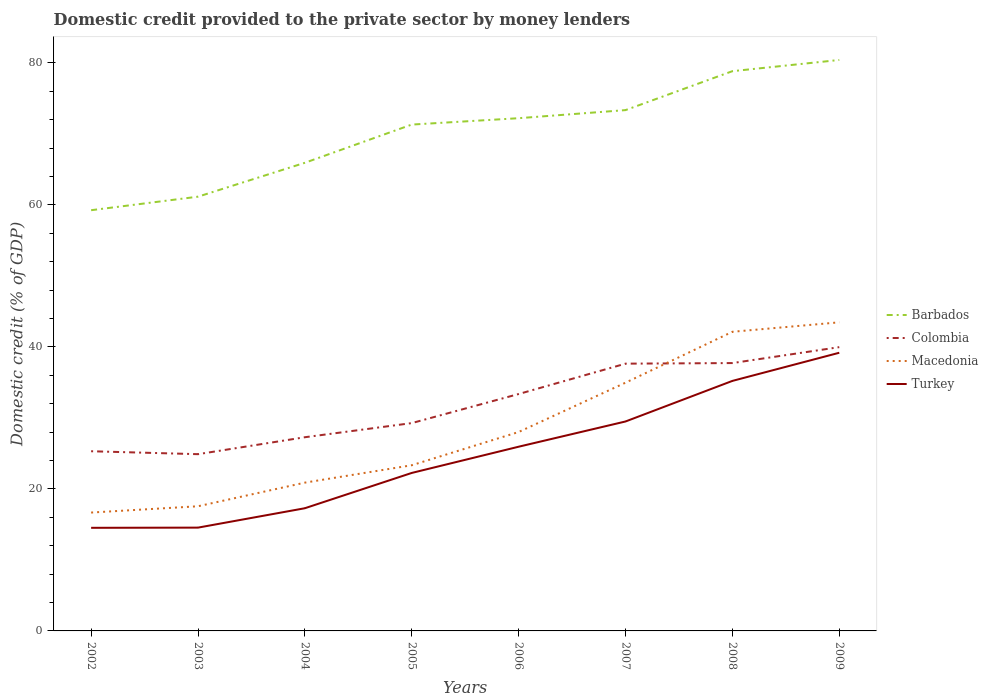Does the line corresponding to Colombia intersect with the line corresponding to Macedonia?
Ensure brevity in your answer.  Yes. Across all years, what is the maximum domestic credit provided to the private sector by money lenders in Macedonia?
Give a very brief answer. 16.67. What is the total domestic credit provided to the private sector by money lenders in Colombia in the graph?
Provide a short and direct response. -6.09. What is the difference between the highest and the second highest domestic credit provided to the private sector by money lenders in Colombia?
Give a very brief answer. 15.07. How many lines are there?
Offer a terse response. 4. How many years are there in the graph?
Ensure brevity in your answer.  8. What is the difference between two consecutive major ticks on the Y-axis?
Make the answer very short. 20. Are the values on the major ticks of Y-axis written in scientific E-notation?
Your answer should be compact. No. Does the graph contain grids?
Provide a short and direct response. No. Where does the legend appear in the graph?
Make the answer very short. Center right. How many legend labels are there?
Your response must be concise. 4. What is the title of the graph?
Keep it short and to the point. Domestic credit provided to the private sector by money lenders. Does "Serbia" appear as one of the legend labels in the graph?
Make the answer very short. No. What is the label or title of the Y-axis?
Provide a succinct answer. Domestic credit (% of GDP). What is the Domestic credit (% of GDP) in Barbados in 2002?
Offer a very short reply. 59.25. What is the Domestic credit (% of GDP) of Colombia in 2002?
Your response must be concise. 25.3. What is the Domestic credit (% of GDP) of Macedonia in 2002?
Provide a short and direct response. 16.67. What is the Domestic credit (% of GDP) of Turkey in 2002?
Offer a very short reply. 14.52. What is the Domestic credit (% of GDP) of Barbados in 2003?
Keep it short and to the point. 61.15. What is the Domestic credit (% of GDP) in Colombia in 2003?
Keep it short and to the point. 24.89. What is the Domestic credit (% of GDP) of Macedonia in 2003?
Ensure brevity in your answer.  17.56. What is the Domestic credit (% of GDP) in Turkey in 2003?
Your answer should be compact. 14.55. What is the Domestic credit (% of GDP) of Barbados in 2004?
Make the answer very short. 65.93. What is the Domestic credit (% of GDP) of Colombia in 2004?
Make the answer very short. 27.28. What is the Domestic credit (% of GDP) in Macedonia in 2004?
Offer a terse response. 20.88. What is the Domestic credit (% of GDP) of Turkey in 2004?
Keep it short and to the point. 17.28. What is the Domestic credit (% of GDP) of Barbados in 2005?
Give a very brief answer. 71.31. What is the Domestic credit (% of GDP) of Colombia in 2005?
Ensure brevity in your answer.  29.27. What is the Domestic credit (% of GDP) of Macedonia in 2005?
Your answer should be very brief. 23.33. What is the Domestic credit (% of GDP) of Turkey in 2005?
Provide a succinct answer. 22.25. What is the Domestic credit (% of GDP) in Barbados in 2006?
Your response must be concise. 72.21. What is the Domestic credit (% of GDP) in Colombia in 2006?
Your response must be concise. 33.36. What is the Domestic credit (% of GDP) in Macedonia in 2006?
Provide a short and direct response. 28.01. What is the Domestic credit (% of GDP) in Turkey in 2006?
Give a very brief answer. 25.94. What is the Domestic credit (% of GDP) in Barbados in 2007?
Offer a terse response. 73.35. What is the Domestic credit (% of GDP) in Colombia in 2007?
Offer a very short reply. 37.64. What is the Domestic credit (% of GDP) in Macedonia in 2007?
Give a very brief answer. 34.96. What is the Domestic credit (% of GDP) in Turkey in 2007?
Make the answer very short. 29.5. What is the Domestic credit (% of GDP) in Barbados in 2008?
Keep it short and to the point. 78.83. What is the Domestic credit (% of GDP) of Colombia in 2008?
Offer a very short reply. 37.72. What is the Domestic credit (% of GDP) in Macedonia in 2008?
Your answer should be very brief. 42.13. What is the Domestic credit (% of GDP) in Turkey in 2008?
Your answer should be compact. 35.21. What is the Domestic credit (% of GDP) in Barbados in 2009?
Your response must be concise. 80.41. What is the Domestic credit (% of GDP) of Colombia in 2009?
Your answer should be very brief. 39.96. What is the Domestic credit (% of GDP) of Macedonia in 2009?
Your answer should be compact. 43.46. What is the Domestic credit (% of GDP) in Turkey in 2009?
Provide a succinct answer. 39.18. Across all years, what is the maximum Domestic credit (% of GDP) in Barbados?
Your answer should be very brief. 80.41. Across all years, what is the maximum Domestic credit (% of GDP) of Colombia?
Your answer should be compact. 39.96. Across all years, what is the maximum Domestic credit (% of GDP) of Macedonia?
Ensure brevity in your answer.  43.46. Across all years, what is the maximum Domestic credit (% of GDP) of Turkey?
Keep it short and to the point. 39.18. Across all years, what is the minimum Domestic credit (% of GDP) in Barbados?
Your answer should be compact. 59.25. Across all years, what is the minimum Domestic credit (% of GDP) in Colombia?
Provide a short and direct response. 24.89. Across all years, what is the minimum Domestic credit (% of GDP) of Macedonia?
Make the answer very short. 16.67. Across all years, what is the minimum Domestic credit (% of GDP) of Turkey?
Provide a succinct answer. 14.52. What is the total Domestic credit (% of GDP) of Barbados in the graph?
Provide a short and direct response. 562.43. What is the total Domestic credit (% of GDP) of Colombia in the graph?
Your response must be concise. 255.43. What is the total Domestic credit (% of GDP) in Macedonia in the graph?
Provide a short and direct response. 227. What is the total Domestic credit (% of GDP) in Turkey in the graph?
Offer a very short reply. 198.42. What is the difference between the Domestic credit (% of GDP) of Barbados in 2002 and that in 2003?
Ensure brevity in your answer.  -1.91. What is the difference between the Domestic credit (% of GDP) of Colombia in 2002 and that in 2003?
Provide a succinct answer. 0.41. What is the difference between the Domestic credit (% of GDP) in Macedonia in 2002 and that in 2003?
Provide a short and direct response. -0.89. What is the difference between the Domestic credit (% of GDP) of Turkey in 2002 and that in 2003?
Offer a very short reply. -0.03. What is the difference between the Domestic credit (% of GDP) of Barbados in 2002 and that in 2004?
Your response must be concise. -6.68. What is the difference between the Domestic credit (% of GDP) of Colombia in 2002 and that in 2004?
Offer a terse response. -1.97. What is the difference between the Domestic credit (% of GDP) of Macedonia in 2002 and that in 2004?
Make the answer very short. -4.21. What is the difference between the Domestic credit (% of GDP) in Turkey in 2002 and that in 2004?
Offer a terse response. -2.76. What is the difference between the Domestic credit (% of GDP) in Barbados in 2002 and that in 2005?
Provide a short and direct response. -12.06. What is the difference between the Domestic credit (% of GDP) of Colombia in 2002 and that in 2005?
Make the answer very short. -3.96. What is the difference between the Domestic credit (% of GDP) of Macedonia in 2002 and that in 2005?
Your answer should be compact. -6.66. What is the difference between the Domestic credit (% of GDP) of Turkey in 2002 and that in 2005?
Your answer should be very brief. -7.73. What is the difference between the Domestic credit (% of GDP) in Barbados in 2002 and that in 2006?
Your response must be concise. -12.96. What is the difference between the Domestic credit (% of GDP) of Colombia in 2002 and that in 2006?
Your response must be concise. -8.06. What is the difference between the Domestic credit (% of GDP) in Macedonia in 2002 and that in 2006?
Your response must be concise. -11.34. What is the difference between the Domestic credit (% of GDP) in Turkey in 2002 and that in 2006?
Give a very brief answer. -11.42. What is the difference between the Domestic credit (% of GDP) of Barbados in 2002 and that in 2007?
Offer a terse response. -14.1. What is the difference between the Domestic credit (% of GDP) in Colombia in 2002 and that in 2007?
Offer a very short reply. -12.34. What is the difference between the Domestic credit (% of GDP) in Macedonia in 2002 and that in 2007?
Ensure brevity in your answer.  -18.29. What is the difference between the Domestic credit (% of GDP) in Turkey in 2002 and that in 2007?
Provide a succinct answer. -14.97. What is the difference between the Domestic credit (% of GDP) of Barbados in 2002 and that in 2008?
Ensure brevity in your answer.  -19.58. What is the difference between the Domestic credit (% of GDP) of Colombia in 2002 and that in 2008?
Give a very brief answer. -12.42. What is the difference between the Domestic credit (% of GDP) in Macedonia in 2002 and that in 2008?
Provide a succinct answer. -25.46. What is the difference between the Domestic credit (% of GDP) of Turkey in 2002 and that in 2008?
Offer a very short reply. -20.69. What is the difference between the Domestic credit (% of GDP) in Barbados in 2002 and that in 2009?
Your response must be concise. -21.16. What is the difference between the Domestic credit (% of GDP) in Colombia in 2002 and that in 2009?
Provide a short and direct response. -14.66. What is the difference between the Domestic credit (% of GDP) in Macedonia in 2002 and that in 2009?
Provide a succinct answer. -26.79. What is the difference between the Domestic credit (% of GDP) in Turkey in 2002 and that in 2009?
Provide a short and direct response. -24.65. What is the difference between the Domestic credit (% of GDP) of Barbados in 2003 and that in 2004?
Offer a terse response. -4.77. What is the difference between the Domestic credit (% of GDP) in Colombia in 2003 and that in 2004?
Your answer should be compact. -2.39. What is the difference between the Domestic credit (% of GDP) of Macedonia in 2003 and that in 2004?
Offer a terse response. -3.33. What is the difference between the Domestic credit (% of GDP) of Turkey in 2003 and that in 2004?
Your response must be concise. -2.73. What is the difference between the Domestic credit (% of GDP) in Barbados in 2003 and that in 2005?
Provide a succinct answer. -10.15. What is the difference between the Domestic credit (% of GDP) of Colombia in 2003 and that in 2005?
Your answer should be compact. -4.38. What is the difference between the Domestic credit (% of GDP) in Macedonia in 2003 and that in 2005?
Give a very brief answer. -5.78. What is the difference between the Domestic credit (% of GDP) of Turkey in 2003 and that in 2005?
Provide a succinct answer. -7.7. What is the difference between the Domestic credit (% of GDP) of Barbados in 2003 and that in 2006?
Your answer should be compact. -11.05. What is the difference between the Domestic credit (% of GDP) of Colombia in 2003 and that in 2006?
Ensure brevity in your answer.  -8.47. What is the difference between the Domestic credit (% of GDP) of Macedonia in 2003 and that in 2006?
Give a very brief answer. -10.46. What is the difference between the Domestic credit (% of GDP) of Turkey in 2003 and that in 2006?
Keep it short and to the point. -11.4. What is the difference between the Domestic credit (% of GDP) of Barbados in 2003 and that in 2007?
Your answer should be compact. -12.19. What is the difference between the Domestic credit (% of GDP) in Colombia in 2003 and that in 2007?
Make the answer very short. -12.75. What is the difference between the Domestic credit (% of GDP) in Macedonia in 2003 and that in 2007?
Offer a very short reply. -17.41. What is the difference between the Domestic credit (% of GDP) in Turkey in 2003 and that in 2007?
Give a very brief answer. -14.95. What is the difference between the Domestic credit (% of GDP) of Barbados in 2003 and that in 2008?
Give a very brief answer. -17.67. What is the difference between the Domestic credit (% of GDP) of Colombia in 2003 and that in 2008?
Make the answer very short. -12.83. What is the difference between the Domestic credit (% of GDP) of Macedonia in 2003 and that in 2008?
Offer a very short reply. -24.57. What is the difference between the Domestic credit (% of GDP) in Turkey in 2003 and that in 2008?
Your answer should be compact. -20.66. What is the difference between the Domestic credit (% of GDP) in Barbados in 2003 and that in 2009?
Keep it short and to the point. -19.25. What is the difference between the Domestic credit (% of GDP) in Colombia in 2003 and that in 2009?
Make the answer very short. -15.07. What is the difference between the Domestic credit (% of GDP) of Macedonia in 2003 and that in 2009?
Keep it short and to the point. -25.9. What is the difference between the Domestic credit (% of GDP) of Turkey in 2003 and that in 2009?
Make the answer very short. -24.63. What is the difference between the Domestic credit (% of GDP) in Barbados in 2004 and that in 2005?
Give a very brief answer. -5.38. What is the difference between the Domestic credit (% of GDP) of Colombia in 2004 and that in 2005?
Offer a very short reply. -1.99. What is the difference between the Domestic credit (% of GDP) of Macedonia in 2004 and that in 2005?
Offer a very short reply. -2.45. What is the difference between the Domestic credit (% of GDP) of Turkey in 2004 and that in 2005?
Provide a short and direct response. -4.97. What is the difference between the Domestic credit (% of GDP) of Barbados in 2004 and that in 2006?
Your response must be concise. -6.28. What is the difference between the Domestic credit (% of GDP) of Colombia in 2004 and that in 2006?
Give a very brief answer. -6.09. What is the difference between the Domestic credit (% of GDP) of Macedonia in 2004 and that in 2006?
Provide a succinct answer. -7.13. What is the difference between the Domestic credit (% of GDP) in Turkey in 2004 and that in 2006?
Provide a short and direct response. -8.66. What is the difference between the Domestic credit (% of GDP) of Barbados in 2004 and that in 2007?
Offer a terse response. -7.42. What is the difference between the Domestic credit (% of GDP) in Colombia in 2004 and that in 2007?
Keep it short and to the point. -10.36. What is the difference between the Domestic credit (% of GDP) of Macedonia in 2004 and that in 2007?
Your answer should be compact. -14.08. What is the difference between the Domestic credit (% of GDP) in Turkey in 2004 and that in 2007?
Give a very brief answer. -12.22. What is the difference between the Domestic credit (% of GDP) of Barbados in 2004 and that in 2008?
Make the answer very short. -12.9. What is the difference between the Domestic credit (% of GDP) in Colombia in 2004 and that in 2008?
Your answer should be compact. -10.44. What is the difference between the Domestic credit (% of GDP) of Macedonia in 2004 and that in 2008?
Your answer should be compact. -21.24. What is the difference between the Domestic credit (% of GDP) in Turkey in 2004 and that in 2008?
Your answer should be very brief. -17.93. What is the difference between the Domestic credit (% of GDP) of Barbados in 2004 and that in 2009?
Your answer should be very brief. -14.48. What is the difference between the Domestic credit (% of GDP) in Colombia in 2004 and that in 2009?
Offer a terse response. -12.69. What is the difference between the Domestic credit (% of GDP) in Macedonia in 2004 and that in 2009?
Your response must be concise. -22.58. What is the difference between the Domestic credit (% of GDP) in Turkey in 2004 and that in 2009?
Offer a terse response. -21.9. What is the difference between the Domestic credit (% of GDP) in Barbados in 2005 and that in 2006?
Give a very brief answer. -0.9. What is the difference between the Domestic credit (% of GDP) of Colombia in 2005 and that in 2006?
Make the answer very short. -4.1. What is the difference between the Domestic credit (% of GDP) in Macedonia in 2005 and that in 2006?
Your answer should be very brief. -4.68. What is the difference between the Domestic credit (% of GDP) in Turkey in 2005 and that in 2006?
Your answer should be very brief. -3.69. What is the difference between the Domestic credit (% of GDP) of Barbados in 2005 and that in 2007?
Offer a very short reply. -2.04. What is the difference between the Domestic credit (% of GDP) of Colombia in 2005 and that in 2007?
Your answer should be very brief. -8.37. What is the difference between the Domestic credit (% of GDP) of Macedonia in 2005 and that in 2007?
Offer a terse response. -11.63. What is the difference between the Domestic credit (% of GDP) in Turkey in 2005 and that in 2007?
Provide a short and direct response. -7.25. What is the difference between the Domestic credit (% of GDP) in Barbados in 2005 and that in 2008?
Offer a terse response. -7.52. What is the difference between the Domestic credit (% of GDP) in Colombia in 2005 and that in 2008?
Keep it short and to the point. -8.45. What is the difference between the Domestic credit (% of GDP) of Macedonia in 2005 and that in 2008?
Your response must be concise. -18.8. What is the difference between the Domestic credit (% of GDP) of Turkey in 2005 and that in 2008?
Your answer should be very brief. -12.96. What is the difference between the Domestic credit (% of GDP) in Barbados in 2005 and that in 2009?
Your answer should be compact. -9.1. What is the difference between the Domestic credit (% of GDP) in Colombia in 2005 and that in 2009?
Give a very brief answer. -10.7. What is the difference between the Domestic credit (% of GDP) in Macedonia in 2005 and that in 2009?
Make the answer very short. -20.13. What is the difference between the Domestic credit (% of GDP) in Turkey in 2005 and that in 2009?
Your answer should be very brief. -16.93. What is the difference between the Domestic credit (% of GDP) in Barbados in 2006 and that in 2007?
Your response must be concise. -1.14. What is the difference between the Domestic credit (% of GDP) in Colombia in 2006 and that in 2007?
Provide a short and direct response. -4.28. What is the difference between the Domestic credit (% of GDP) in Macedonia in 2006 and that in 2007?
Your answer should be compact. -6.95. What is the difference between the Domestic credit (% of GDP) in Turkey in 2006 and that in 2007?
Give a very brief answer. -3.55. What is the difference between the Domestic credit (% of GDP) in Barbados in 2006 and that in 2008?
Your answer should be very brief. -6.62. What is the difference between the Domestic credit (% of GDP) of Colombia in 2006 and that in 2008?
Keep it short and to the point. -4.36. What is the difference between the Domestic credit (% of GDP) in Macedonia in 2006 and that in 2008?
Ensure brevity in your answer.  -14.11. What is the difference between the Domestic credit (% of GDP) of Turkey in 2006 and that in 2008?
Make the answer very short. -9.27. What is the difference between the Domestic credit (% of GDP) of Barbados in 2006 and that in 2009?
Give a very brief answer. -8.2. What is the difference between the Domestic credit (% of GDP) of Colombia in 2006 and that in 2009?
Provide a succinct answer. -6.6. What is the difference between the Domestic credit (% of GDP) of Macedonia in 2006 and that in 2009?
Your answer should be compact. -15.45. What is the difference between the Domestic credit (% of GDP) of Turkey in 2006 and that in 2009?
Offer a very short reply. -13.23. What is the difference between the Domestic credit (% of GDP) of Barbados in 2007 and that in 2008?
Provide a succinct answer. -5.48. What is the difference between the Domestic credit (% of GDP) of Colombia in 2007 and that in 2008?
Ensure brevity in your answer.  -0.08. What is the difference between the Domestic credit (% of GDP) of Macedonia in 2007 and that in 2008?
Ensure brevity in your answer.  -7.17. What is the difference between the Domestic credit (% of GDP) of Turkey in 2007 and that in 2008?
Offer a very short reply. -5.71. What is the difference between the Domestic credit (% of GDP) in Barbados in 2007 and that in 2009?
Your answer should be very brief. -7.06. What is the difference between the Domestic credit (% of GDP) of Colombia in 2007 and that in 2009?
Make the answer very short. -2.33. What is the difference between the Domestic credit (% of GDP) of Macedonia in 2007 and that in 2009?
Keep it short and to the point. -8.5. What is the difference between the Domestic credit (% of GDP) in Turkey in 2007 and that in 2009?
Give a very brief answer. -9.68. What is the difference between the Domestic credit (% of GDP) in Barbados in 2008 and that in 2009?
Make the answer very short. -1.58. What is the difference between the Domestic credit (% of GDP) in Colombia in 2008 and that in 2009?
Make the answer very short. -2.24. What is the difference between the Domestic credit (% of GDP) in Macedonia in 2008 and that in 2009?
Offer a very short reply. -1.33. What is the difference between the Domestic credit (% of GDP) of Turkey in 2008 and that in 2009?
Give a very brief answer. -3.96. What is the difference between the Domestic credit (% of GDP) in Barbados in 2002 and the Domestic credit (% of GDP) in Colombia in 2003?
Ensure brevity in your answer.  34.36. What is the difference between the Domestic credit (% of GDP) of Barbados in 2002 and the Domestic credit (% of GDP) of Macedonia in 2003?
Your answer should be very brief. 41.69. What is the difference between the Domestic credit (% of GDP) in Barbados in 2002 and the Domestic credit (% of GDP) in Turkey in 2003?
Provide a succinct answer. 44.7. What is the difference between the Domestic credit (% of GDP) of Colombia in 2002 and the Domestic credit (% of GDP) of Macedonia in 2003?
Your answer should be compact. 7.75. What is the difference between the Domestic credit (% of GDP) in Colombia in 2002 and the Domestic credit (% of GDP) in Turkey in 2003?
Offer a terse response. 10.76. What is the difference between the Domestic credit (% of GDP) of Macedonia in 2002 and the Domestic credit (% of GDP) of Turkey in 2003?
Offer a terse response. 2.12. What is the difference between the Domestic credit (% of GDP) of Barbados in 2002 and the Domestic credit (% of GDP) of Colombia in 2004?
Keep it short and to the point. 31.97. What is the difference between the Domestic credit (% of GDP) in Barbados in 2002 and the Domestic credit (% of GDP) in Macedonia in 2004?
Make the answer very short. 38.36. What is the difference between the Domestic credit (% of GDP) of Barbados in 2002 and the Domestic credit (% of GDP) of Turkey in 2004?
Provide a short and direct response. 41.97. What is the difference between the Domestic credit (% of GDP) in Colombia in 2002 and the Domestic credit (% of GDP) in Macedonia in 2004?
Provide a short and direct response. 4.42. What is the difference between the Domestic credit (% of GDP) in Colombia in 2002 and the Domestic credit (% of GDP) in Turkey in 2004?
Your answer should be very brief. 8.02. What is the difference between the Domestic credit (% of GDP) in Macedonia in 2002 and the Domestic credit (% of GDP) in Turkey in 2004?
Your response must be concise. -0.61. What is the difference between the Domestic credit (% of GDP) in Barbados in 2002 and the Domestic credit (% of GDP) in Colombia in 2005?
Make the answer very short. 29.98. What is the difference between the Domestic credit (% of GDP) of Barbados in 2002 and the Domestic credit (% of GDP) of Macedonia in 2005?
Give a very brief answer. 35.92. What is the difference between the Domestic credit (% of GDP) of Barbados in 2002 and the Domestic credit (% of GDP) of Turkey in 2005?
Provide a succinct answer. 37. What is the difference between the Domestic credit (% of GDP) in Colombia in 2002 and the Domestic credit (% of GDP) in Macedonia in 2005?
Keep it short and to the point. 1.97. What is the difference between the Domestic credit (% of GDP) of Colombia in 2002 and the Domestic credit (% of GDP) of Turkey in 2005?
Keep it short and to the point. 3.05. What is the difference between the Domestic credit (% of GDP) of Macedonia in 2002 and the Domestic credit (% of GDP) of Turkey in 2005?
Your response must be concise. -5.58. What is the difference between the Domestic credit (% of GDP) of Barbados in 2002 and the Domestic credit (% of GDP) of Colombia in 2006?
Provide a short and direct response. 25.89. What is the difference between the Domestic credit (% of GDP) in Barbados in 2002 and the Domestic credit (% of GDP) in Macedonia in 2006?
Ensure brevity in your answer.  31.23. What is the difference between the Domestic credit (% of GDP) in Barbados in 2002 and the Domestic credit (% of GDP) in Turkey in 2006?
Ensure brevity in your answer.  33.31. What is the difference between the Domestic credit (% of GDP) in Colombia in 2002 and the Domestic credit (% of GDP) in Macedonia in 2006?
Make the answer very short. -2.71. What is the difference between the Domestic credit (% of GDP) in Colombia in 2002 and the Domestic credit (% of GDP) in Turkey in 2006?
Your answer should be compact. -0.64. What is the difference between the Domestic credit (% of GDP) in Macedonia in 2002 and the Domestic credit (% of GDP) in Turkey in 2006?
Your answer should be compact. -9.27. What is the difference between the Domestic credit (% of GDP) of Barbados in 2002 and the Domestic credit (% of GDP) of Colombia in 2007?
Your answer should be compact. 21.61. What is the difference between the Domestic credit (% of GDP) of Barbados in 2002 and the Domestic credit (% of GDP) of Macedonia in 2007?
Offer a very short reply. 24.29. What is the difference between the Domestic credit (% of GDP) of Barbados in 2002 and the Domestic credit (% of GDP) of Turkey in 2007?
Offer a terse response. 29.75. What is the difference between the Domestic credit (% of GDP) in Colombia in 2002 and the Domestic credit (% of GDP) in Macedonia in 2007?
Keep it short and to the point. -9.66. What is the difference between the Domestic credit (% of GDP) of Colombia in 2002 and the Domestic credit (% of GDP) of Turkey in 2007?
Offer a terse response. -4.19. What is the difference between the Domestic credit (% of GDP) in Macedonia in 2002 and the Domestic credit (% of GDP) in Turkey in 2007?
Offer a very short reply. -12.83. What is the difference between the Domestic credit (% of GDP) of Barbados in 2002 and the Domestic credit (% of GDP) of Colombia in 2008?
Keep it short and to the point. 21.53. What is the difference between the Domestic credit (% of GDP) of Barbados in 2002 and the Domestic credit (% of GDP) of Macedonia in 2008?
Your answer should be compact. 17.12. What is the difference between the Domestic credit (% of GDP) in Barbados in 2002 and the Domestic credit (% of GDP) in Turkey in 2008?
Provide a short and direct response. 24.04. What is the difference between the Domestic credit (% of GDP) of Colombia in 2002 and the Domestic credit (% of GDP) of Macedonia in 2008?
Provide a short and direct response. -16.82. What is the difference between the Domestic credit (% of GDP) in Colombia in 2002 and the Domestic credit (% of GDP) in Turkey in 2008?
Offer a terse response. -9.91. What is the difference between the Domestic credit (% of GDP) of Macedonia in 2002 and the Domestic credit (% of GDP) of Turkey in 2008?
Offer a terse response. -18.54. What is the difference between the Domestic credit (% of GDP) in Barbados in 2002 and the Domestic credit (% of GDP) in Colombia in 2009?
Give a very brief answer. 19.28. What is the difference between the Domestic credit (% of GDP) of Barbados in 2002 and the Domestic credit (% of GDP) of Macedonia in 2009?
Offer a very short reply. 15.79. What is the difference between the Domestic credit (% of GDP) in Barbados in 2002 and the Domestic credit (% of GDP) in Turkey in 2009?
Ensure brevity in your answer.  20.07. What is the difference between the Domestic credit (% of GDP) of Colombia in 2002 and the Domestic credit (% of GDP) of Macedonia in 2009?
Your response must be concise. -18.16. What is the difference between the Domestic credit (% of GDP) of Colombia in 2002 and the Domestic credit (% of GDP) of Turkey in 2009?
Offer a terse response. -13.87. What is the difference between the Domestic credit (% of GDP) in Macedonia in 2002 and the Domestic credit (% of GDP) in Turkey in 2009?
Offer a terse response. -22.51. What is the difference between the Domestic credit (% of GDP) in Barbados in 2003 and the Domestic credit (% of GDP) in Colombia in 2004?
Make the answer very short. 33.88. What is the difference between the Domestic credit (% of GDP) in Barbados in 2003 and the Domestic credit (% of GDP) in Macedonia in 2004?
Offer a very short reply. 40.27. What is the difference between the Domestic credit (% of GDP) of Barbados in 2003 and the Domestic credit (% of GDP) of Turkey in 2004?
Provide a succinct answer. 43.88. What is the difference between the Domestic credit (% of GDP) in Colombia in 2003 and the Domestic credit (% of GDP) in Macedonia in 2004?
Offer a very short reply. 4.01. What is the difference between the Domestic credit (% of GDP) of Colombia in 2003 and the Domestic credit (% of GDP) of Turkey in 2004?
Offer a terse response. 7.61. What is the difference between the Domestic credit (% of GDP) in Macedonia in 2003 and the Domestic credit (% of GDP) in Turkey in 2004?
Provide a short and direct response. 0.28. What is the difference between the Domestic credit (% of GDP) in Barbados in 2003 and the Domestic credit (% of GDP) in Colombia in 2005?
Your answer should be compact. 31.89. What is the difference between the Domestic credit (% of GDP) in Barbados in 2003 and the Domestic credit (% of GDP) in Macedonia in 2005?
Your response must be concise. 37.82. What is the difference between the Domestic credit (% of GDP) in Barbados in 2003 and the Domestic credit (% of GDP) in Turkey in 2005?
Provide a short and direct response. 38.91. What is the difference between the Domestic credit (% of GDP) in Colombia in 2003 and the Domestic credit (% of GDP) in Macedonia in 2005?
Your answer should be very brief. 1.56. What is the difference between the Domestic credit (% of GDP) in Colombia in 2003 and the Domestic credit (% of GDP) in Turkey in 2005?
Keep it short and to the point. 2.64. What is the difference between the Domestic credit (% of GDP) of Macedonia in 2003 and the Domestic credit (% of GDP) of Turkey in 2005?
Give a very brief answer. -4.69. What is the difference between the Domestic credit (% of GDP) of Barbados in 2003 and the Domestic credit (% of GDP) of Colombia in 2006?
Your answer should be compact. 27.79. What is the difference between the Domestic credit (% of GDP) of Barbados in 2003 and the Domestic credit (% of GDP) of Macedonia in 2006?
Provide a succinct answer. 33.14. What is the difference between the Domestic credit (% of GDP) of Barbados in 2003 and the Domestic credit (% of GDP) of Turkey in 2006?
Your response must be concise. 35.21. What is the difference between the Domestic credit (% of GDP) of Colombia in 2003 and the Domestic credit (% of GDP) of Macedonia in 2006?
Offer a very short reply. -3.12. What is the difference between the Domestic credit (% of GDP) in Colombia in 2003 and the Domestic credit (% of GDP) in Turkey in 2006?
Provide a short and direct response. -1.05. What is the difference between the Domestic credit (% of GDP) of Macedonia in 2003 and the Domestic credit (% of GDP) of Turkey in 2006?
Your answer should be very brief. -8.39. What is the difference between the Domestic credit (% of GDP) of Barbados in 2003 and the Domestic credit (% of GDP) of Colombia in 2007?
Give a very brief answer. 23.52. What is the difference between the Domestic credit (% of GDP) in Barbados in 2003 and the Domestic credit (% of GDP) in Macedonia in 2007?
Your response must be concise. 26.19. What is the difference between the Domestic credit (% of GDP) of Barbados in 2003 and the Domestic credit (% of GDP) of Turkey in 2007?
Your response must be concise. 31.66. What is the difference between the Domestic credit (% of GDP) of Colombia in 2003 and the Domestic credit (% of GDP) of Macedonia in 2007?
Keep it short and to the point. -10.07. What is the difference between the Domestic credit (% of GDP) of Colombia in 2003 and the Domestic credit (% of GDP) of Turkey in 2007?
Give a very brief answer. -4.6. What is the difference between the Domestic credit (% of GDP) of Macedonia in 2003 and the Domestic credit (% of GDP) of Turkey in 2007?
Give a very brief answer. -11.94. What is the difference between the Domestic credit (% of GDP) of Barbados in 2003 and the Domestic credit (% of GDP) of Colombia in 2008?
Ensure brevity in your answer.  23.43. What is the difference between the Domestic credit (% of GDP) in Barbados in 2003 and the Domestic credit (% of GDP) in Macedonia in 2008?
Offer a very short reply. 19.03. What is the difference between the Domestic credit (% of GDP) in Barbados in 2003 and the Domestic credit (% of GDP) in Turkey in 2008?
Your answer should be very brief. 25.94. What is the difference between the Domestic credit (% of GDP) of Colombia in 2003 and the Domestic credit (% of GDP) of Macedonia in 2008?
Offer a very short reply. -17.24. What is the difference between the Domestic credit (% of GDP) of Colombia in 2003 and the Domestic credit (% of GDP) of Turkey in 2008?
Make the answer very short. -10.32. What is the difference between the Domestic credit (% of GDP) of Macedonia in 2003 and the Domestic credit (% of GDP) of Turkey in 2008?
Give a very brief answer. -17.65. What is the difference between the Domestic credit (% of GDP) of Barbados in 2003 and the Domestic credit (% of GDP) of Colombia in 2009?
Your answer should be very brief. 21.19. What is the difference between the Domestic credit (% of GDP) in Barbados in 2003 and the Domestic credit (% of GDP) in Macedonia in 2009?
Provide a succinct answer. 17.69. What is the difference between the Domestic credit (% of GDP) in Barbados in 2003 and the Domestic credit (% of GDP) in Turkey in 2009?
Your answer should be compact. 21.98. What is the difference between the Domestic credit (% of GDP) of Colombia in 2003 and the Domestic credit (% of GDP) of Macedonia in 2009?
Ensure brevity in your answer.  -18.57. What is the difference between the Domestic credit (% of GDP) of Colombia in 2003 and the Domestic credit (% of GDP) of Turkey in 2009?
Provide a short and direct response. -14.28. What is the difference between the Domestic credit (% of GDP) in Macedonia in 2003 and the Domestic credit (% of GDP) in Turkey in 2009?
Ensure brevity in your answer.  -21.62. What is the difference between the Domestic credit (% of GDP) in Barbados in 2004 and the Domestic credit (% of GDP) in Colombia in 2005?
Provide a short and direct response. 36.66. What is the difference between the Domestic credit (% of GDP) in Barbados in 2004 and the Domestic credit (% of GDP) in Macedonia in 2005?
Keep it short and to the point. 42.6. What is the difference between the Domestic credit (% of GDP) in Barbados in 2004 and the Domestic credit (% of GDP) in Turkey in 2005?
Provide a succinct answer. 43.68. What is the difference between the Domestic credit (% of GDP) of Colombia in 2004 and the Domestic credit (% of GDP) of Macedonia in 2005?
Give a very brief answer. 3.95. What is the difference between the Domestic credit (% of GDP) in Colombia in 2004 and the Domestic credit (% of GDP) in Turkey in 2005?
Offer a very short reply. 5.03. What is the difference between the Domestic credit (% of GDP) in Macedonia in 2004 and the Domestic credit (% of GDP) in Turkey in 2005?
Offer a very short reply. -1.36. What is the difference between the Domestic credit (% of GDP) in Barbados in 2004 and the Domestic credit (% of GDP) in Colombia in 2006?
Provide a short and direct response. 32.57. What is the difference between the Domestic credit (% of GDP) of Barbados in 2004 and the Domestic credit (% of GDP) of Macedonia in 2006?
Ensure brevity in your answer.  37.91. What is the difference between the Domestic credit (% of GDP) of Barbados in 2004 and the Domestic credit (% of GDP) of Turkey in 2006?
Your answer should be compact. 39.99. What is the difference between the Domestic credit (% of GDP) of Colombia in 2004 and the Domestic credit (% of GDP) of Macedonia in 2006?
Offer a very short reply. -0.74. What is the difference between the Domestic credit (% of GDP) in Colombia in 2004 and the Domestic credit (% of GDP) in Turkey in 2006?
Ensure brevity in your answer.  1.34. What is the difference between the Domestic credit (% of GDP) of Macedonia in 2004 and the Domestic credit (% of GDP) of Turkey in 2006?
Offer a very short reply. -5.06. What is the difference between the Domestic credit (% of GDP) in Barbados in 2004 and the Domestic credit (% of GDP) in Colombia in 2007?
Give a very brief answer. 28.29. What is the difference between the Domestic credit (% of GDP) of Barbados in 2004 and the Domestic credit (% of GDP) of Macedonia in 2007?
Offer a very short reply. 30.97. What is the difference between the Domestic credit (% of GDP) of Barbados in 2004 and the Domestic credit (% of GDP) of Turkey in 2007?
Your answer should be compact. 36.43. What is the difference between the Domestic credit (% of GDP) in Colombia in 2004 and the Domestic credit (% of GDP) in Macedonia in 2007?
Your answer should be very brief. -7.68. What is the difference between the Domestic credit (% of GDP) in Colombia in 2004 and the Domestic credit (% of GDP) in Turkey in 2007?
Give a very brief answer. -2.22. What is the difference between the Domestic credit (% of GDP) of Macedonia in 2004 and the Domestic credit (% of GDP) of Turkey in 2007?
Offer a terse response. -8.61. What is the difference between the Domestic credit (% of GDP) of Barbados in 2004 and the Domestic credit (% of GDP) of Colombia in 2008?
Ensure brevity in your answer.  28.21. What is the difference between the Domestic credit (% of GDP) in Barbados in 2004 and the Domestic credit (% of GDP) in Macedonia in 2008?
Make the answer very short. 23.8. What is the difference between the Domestic credit (% of GDP) in Barbados in 2004 and the Domestic credit (% of GDP) in Turkey in 2008?
Offer a terse response. 30.72. What is the difference between the Domestic credit (% of GDP) of Colombia in 2004 and the Domestic credit (% of GDP) of Macedonia in 2008?
Ensure brevity in your answer.  -14.85. What is the difference between the Domestic credit (% of GDP) of Colombia in 2004 and the Domestic credit (% of GDP) of Turkey in 2008?
Keep it short and to the point. -7.93. What is the difference between the Domestic credit (% of GDP) in Macedonia in 2004 and the Domestic credit (% of GDP) in Turkey in 2008?
Keep it short and to the point. -14.33. What is the difference between the Domestic credit (% of GDP) in Barbados in 2004 and the Domestic credit (% of GDP) in Colombia in 2009?
Make the answer very short. 25.96. What is the difference between the Domestic credit (% of GDP) of Barbados in 2004 and the Domestic credit (% of GDP) of Macedonia in 2009?
Make the answer very short. 22.47. What is the difference between the Domestic credit (% of GDP) of Barbados in 2004 and the Domestic credit (% of GDP) of Turkey in 2009?
Ensure brevity in your answer.  26.75. What is the difference between the Domestic credit (% of GDP) in Colombia in 2004 and the Domestic credit (% of GDP) in Macedonia in 2009?
Provide a succinct answer. -16.18. What is the difference between the Domestic credit (% of GDP) of Colombia in 2004 and the Domestic credit (% of GDP) of Turkey in 2009?
Provide a short and direct response. -11.9. What is the difference between the Domestic credit (% of GDP) in Macedonia in 2004 and the Domestic credit (% of GDP) in Turkey in 2009?
Provide a succinct answer. -18.29. What is the difference between the Domestic credit (% of GDP) of Barbados in 2005 and the Domestic credit (% of GDP) of Colombia in 2006?
Offer a very short reply. 37.95. What is the difference between the Domestic credit (% of GDP) in Barbados in 2005 and the Domestic credit (% of GDP) in Macedonia in 2006?
Make the answer very short. 43.29. What is the difference between the Domestic credit (% of GDP) in Barbados in 2005 and the Domestic credit (% of GDP) in Turkey in 2006?
Ensure brevity in your answer.  45.37. What is the difference between the Domestic credit (% of GDP) in Colombia in 2005 and the Domestic credit (% of GDP) in Macedonia in 2006?
Provide a short and direct response. 1.25. What is the difference between the Domestic credit (% of GDP) in Colombia in 2005 and the Domestic credit (% of GDP) in Turkey in 2006?
Ensure brevity in your answer.  3.33. What is the difference between the Domestic credit (% of GDP) in Macedonia in 2005 and the Domestic credit (% of GDP) in Turkey in 2006?
Provide a short and direct response. -2.61. What is the difference between the Domestic credit (% of GDP) of Barbados in 2005 and the Domestic credit (% of GDP) of Colombia in 2007?
Make the answer very short. 33.67. What is the difference between the Domestic credit (% of GDP) of Barbados in 2005 and the Domestic credit (% of GDP) of Macedonia in 2007?
Ensure brevity in your answer.  36.35. What is the difference between the Domestic credit (% of GDP) in Barbados in 2005 and the Domestic credit (% of GDP) in Turkey in 2007?
Provide a succinct answer. 41.81. What is the difference between the Domestic credit (% of GDP) in Colombia in 2005 and the Domestic credit (% of GDP) in Macedonia in 2007?
Your answer should be very brief. -5.69. What is the difference between the Domestic credit (% of GDP) of Colombia in 2005 and the Domestic credit (% of GDP) of Turkey in 2007?
Offer a terse response. -0.23. What is the difference between the Domestic credit (% of GDP) in Macedonia in 2005 and the Domestic credit (% of GDP) in Turkey in 2007?
Your response must be concise. -6.16. What is the difference between the Domestic credit (% of GDP) of Barbados in 2005 and the Domestic credit (% of GDP) of Colombia in 2008?
Your answer should be very brief. 33.59. What is the difference between the Domestic credit (% of GDP) in Barbados in 2005 and the Domestic credit (% of GDP) in Macedonia in 2008?
Keep it short and to the point. 29.18. What is the difference between the Domestic credit (% of GDP) of Barbados in 2005 and the Domestic credit (% of GDP) of Turkey in 2008?
Give a very brief answer. 36.1. What is the difference between the Domestic credit (% of GDP) in Colombia in 2005 and the Domestic credit (% of GDP) in Macedonia in 2008?
Ensure brevity in your answer.  -12.86. What is the difference between the Domestic credit (% of GDP) in Colombia in 2005 and the Domestic credit (% of GDP) in Turkey in 2008?
Keep it short and to the point. -5.94. What is the difference between the Domestic credit (% of GDP) of Macedonia in 2005 and the Domestic credit (% of GDP) of Turkey in 2008?
Your answer should be very brief. -11.88. What is the difference between the Domestic credit (% of GDP) of Barbados in 2005 and the Domestic credit (% of GDP) of Colombia in 2009?
Your response must be concise. 31.34. What is the difference between the Domestic credit (% of GDP) in Barbados in 2005 and the Domestic credit (% of GDP) in Macedonia in 2009?
Give a very brief answer. 27.85. What is the difference between the Domestic credit (% of GDP) in Barbados in 2005 and the Domestic credit (% of GDP) in Turkey in 2009?
Provide a succinct answer. 32.13. What is the difference between the Domestic credit (% of GDP) of Colombia in 2005 and the Domestic credit (% of GDP) of Macedonia in 2009?
Offer a terse response. -14.19. What is the difference between the Domestic credit (% of GDP) of Colombia in 2005 and the Domestic credit (% of GDP) of Turkey in 2009?
Your answer should be very brief. -9.91. What is the difference between the Domestic credit (% of GDP) of Macedonia in 2005 and the Domestic credit (% of GDP) of Turkey in 2009?
Offer a very short reply. -15.84. What is the difference between the Domestic credit (% of GDP) in Barbados in 2006 and the Domestic credit (% of GDP) in Colombia in 2007?
Your answer should be compact. 34.57. What is the difference between the Domestic credit (% of GDP) of Barbados in 2006 and the Domestic credit (% of GDP) of Macedonia in 2007?
Offer a terse response. 37.25. What is the difference between the Domestic credit (% of GDP) of Barbados in 2006 and the Domestic credit (% of GDP) of Turkey in 2007?
Your answer should be compact. 42.71. What is the difference between the Domestic credit (% of GDP) of Colombia in 2006 and the Domestic credit (% of GDP) of Macedonia in 2007?
Provide a short and direct response. -1.6. What is the difference between the Domestic credit (% of GDP) of Colombia in 2006 and the Domestic credit (% of GDP) of Turkey in 2007?
Provide a short and direct response. 3.87. What is the difference between the Domestic credit (% of GDP) of Macedonia in 2006 and the Domestic credit (% of GDP) of Turkey in 2007?
Offer a very short reply. -1.48. What is the difference between the Domestic credit (% of GDP) of Barbados in 2006 and the Domestic credit (% of GDP) of Colombia in 2008?
Make the answer very short. 34.49. What is the difference between the Domestic credit (% of GDP) of Barbados in 2006 and the Domestic credit (% of GDP) of Macedonia in 2008?
Your answer should be compact. 30.08. What is the difference between the Domestic credit (% of GDP) of Barbados in 2006 and the Domestic credit (% of GDP) of Turkey in 2008?
Your answer should be very brief. 37. What is the difference between the Domestic credit (% of GDP) of Colombia in 2006 and the Domestic credit (% of GDP) of Macedonia in 2008?
Your response must be concise. -8.76. What is the difference between the Domestic credit (% of GDP) in Colombia in 2006 and the Domestic credit (% of GDP) in Turkey in 2008?
Provide a succinct answer. -1.85. What is the difference between the Domestic credit (% of GDP) in Macedonia in 2006 and the Domestic credit (% of GDP) in Turkey in 2008?
Make the answer very short. -7.2. What is the difference between the Domestic credit (% of GDP) in Barbados in 2006 and the Domestic credit (% of GDP) in Colombia in 2009?
Your answer should be compact. 32.24. What is the difference between the Domestic credit (% of GDP) in Barbados in 2006 and the Domestic credit (% of GDP) in Macedonia in 2009?
Keep it short and to the point. 28.75. What is the difference between the Domestic credit (% of GDP) in Barbados in 2006 and the Domestic credit (% of GDP) in Turkey in 2009?
Your answer should be compact. 33.03. What is the difference between the Domestic credit (% of GDP) in Colombia in 2006 and the Domestic credit (% of GDP) in Macedonia in 2009?
Offer a very short reply. -10.1. What is the difference between the Domestic credit (% of GDP) in Colombia in 2006 and the Domestic credit (% of GDP) in Turkey in 2009?
Your response must be concise. -5.81. What is the difference between the Domestic credit (% of GDP) in Macedonia in 2006 and the Domestic credit (% of GDP) in Turkey in 2009?
Your answer should be very brief. -11.16. What is the difference between the Domestic credit (% of GDP) of Barbados in 2007 and the Domestic credit (% of GDP) of Colombia in 2008?
Give a very brief answer. 35.62. What is the difference between the Domestic credit (% of GDP) in Barbados in 2007 and the Domestic credit (% of GDP) in Macedonia in 2008?
Give a very brief answer. 31.22. What is the difference between the Domestic credit (% of GDP) of Barbados in 2007 and the Domestic credit (% of GDP) of Turkey in 2008?
Offer a very short reply. 38.14. What is the difference between the Domestic credit (% of GDP) in Colombia in 2007 and the Domestic credit (% of GDP) in Macedonia in 2008?
Ensure brevity in your answer.  -4.49. What is the difference between the Domestic credit (% of GDP) in Colombia in 2007 and the Domestic credit (% of GDP) in Turkey in 2008?
Provide a short and direct response. 2.43. What is the difference between the Domestic credit (% of GDP) in Macedonia in 2007 and the Domestic credit (% of GDP) in Turkey in 2008?
Make the answer very short. -0.25. What is the difference between the Domestic credit (% of GDP) of Barbados in 2007 and the Domestic credit (% of GDP) of Colombia in 2009?
Offer a terse response. 33.38. What is the difference between the Domestic credit (% of GDP) of Barbados in 2007 and the Domestic credit (% of GDP) of Macedonia in 2009?
Ensure brevity in your answer.  29.89. What is the difference between the Domestic credit (% of GDP) of Barbados in 2007 and the Domestic credit (% of GDP) of Turkey in 2009?
Make the answer very short. 34.17. What is the difference between the Domestic credit (% of GDP) of Colombia in 2007 and the Domestic credit (% of GDP) of Macedonia in 2009?
Provide a succinct answer. -5.82. What is the difference between the Domestic credit (% of GDP) in Colombia in 2007 and the Domestic credit (% of GDP) in Turkey in 2009?
Ensure brevity in your answer.  -1.54. What is the difference between the Domestic credit (% of GDP) of Macedonia in 2007 and the Domestic credit (% of GDP) of Turkey in 2009?
Your answer should be compact. -4.21. What is the difference between the Domestic credit (% of GDP) in Barbados in 2008 and the Domestic credit (% of GDP) in Colombia in 2009?
Offer a terse response. 38.86. What is the difference between the Domestic credit (% of GDP) of Barbados in 2008 and the Domestic credit (% of GDP) of Macedonia in 2009?
Your answer should be very brief. 35.37. What is the difference between the Domestic credit (% of GDP) of Barbados in 2008 and the Domestic credit (% of GDP) of Turkey in 2009?
Your answer should be compact. 39.65. What is the difference between the Domestic credit (% of GDP) in Colombia in 2008 and the Domestic credit (% of GDP) in Macedonia in 2009?
Offer a terse response. -5.74. What is the difference between the Domestic credit (% of GDP) of Colombia in 2008 and the Domestic credit (% of GDP) of Turkey in 2009?
Your answer should be very brief. -1.45. What is the difference between the Domestic credit (% of GDP) of Macedonia in 2008 and the Domestic credit (% of GDP) of Turkey in 2009?
Keep it short and to the point. 2.95. What is the average Domestic credit (% of GDP) in Barbados per year?
Your answer should be very brief. 70.3. What is the average Domestic credit (% of GDP) of Colombia per year?
Offer a very short reply. 31.93. What is the average Domestic credit (% of GDP) of Macedonia per year?
Your response must be concise. 28.38. What is the average Domestic credit (% of GDP) of Turkey per year?
Make the answer very short. 24.8. In the year 2002, what is the difference between the Domestic credit (% of GDP) in Barbados and Domestic credit (% of GDP) in Colombia?
Give a very brief answer. 33.95. In the year 2002, what is the difference between the Domestic credit (% of GDP) of Barbados and Domestic credit (% of GDP) of Macedonia?
Give a very brief answer. 42.58. In the year 2002, what is the difference between the Domestic credit (% of GDP) in Barbados and Domestic credit (% of GDP) in Turkey?
Provide a succinct answer. 44.73. In the year 2002, what is the difference between the Domestic credit (% of GDP) in Colombia and Domestic credit (% of GDP) in Macedonia?
Your answer should be compact. 8.63. In the year 2002, what is the difference between the Domestic credit (% of GDP) of Colombia and Domestic credit (% of GDP) of Turkey?
Your answer should be very brief. 10.78. In the year 2002, what is the difference between the Domestic credit (% of GDP) in Macedonia and Domestic credit (% of GDP) in Turkey?
Ensure brevity in your answer.  2.15. In the year 2003, what is the difference between the Domestic credit (% of GDP) in Barbados and Domestic credit (% of GDP) in Colombia?
Make the answer very short. 36.26. In the year 2003, what is the difference between the Domestic credit (% of GDP) of Barbados and Domestic credit (% of GDP) of Macedonia?
Make the answer very short. 43.6. In the year 2003, what is the difference between the Domestic credit (% of GDP) of Barbados and Domestic credit (% of GDP) of Turkey?
Your answer should be very brief. 46.61. In the year 2003, what is the difference between the Domestic credit (% of GDP) in Colombia and Domestic credit (% of GDP) in Macedonia?
Your answer should be compact. 7.34. In the year 2003, what is the difference between the Domestic credit (% of GDP) in Colombia and Domestic credit (% of GDP) in Turkey?
Provide a short and direct response. 10.34. In the year 2003, what is the difference between the Domestic credit (% of GDP) in Macedonia and Domestic credit (% of GDP) in Turkey?
Give a very brief answer. 3.01. In the year 2004, what is the difference between the Domestic credit (% of GDP) in Barbados and Domestic credit (% of GDP) in Colombia?
Make the answer very short. 38.65. In the year 2004, what is the difference between the Domestic credit (% of GDP) of Barbados and Domestic credit (% of GDP) of Macedonia?
Your answer should be compact. 45.04. In the year 2004, what is the difference between the Domestic credit (% of GDP) of Barbados and Domestic credit (% of GDP) of Turkey?
Give a very brief answer. 48.65. In the year 2004, what is the difference between the Domestic credit (% of GDP) of Colombia and Domestic credit (% of GDP) of Macedonia?
Provide a short and direct response. 6.39. In the year 2004, what is the difference between the Domestic credit (% of GDP) of Colombia and Domestic credit (% of GDP) of Turkey?
Ensure brevity in your answer.  10. In the year 2004, what is the difference between the Domestic credit (% of GDP) in Macedonia and Domestic credit (% of GDP) in Turkey?
Offer a very short reply. 3.61. In the year 2005, what is the difference between the Domestic credit (% of GDP) of Barbados and Domestic credit (% of GDP) of Colombia?
Provide a succinct answer. 42.04. In the year 2005, what is the difference between the Domestic credit (% of GDP) in Barbados and Domestic credit (% of GDP) in Macedonia?
Offer a very short reply. 47.98. In the year 2005, what is the difference between the Domestic credit (% of GDP) in Barbados and Domestic credit (% of GDP) in Turkey?
Provide a short and direct response. 49.06. In the year 2005, what is the difference between the Domestic credit (% of GDP) in Colombia and Domestic credit (% of GDP) in Macedonia?
Keep it short and to the point. 5.94. In the year 2005, what is the difference between the Domestic credit (% of GDP) in Colombia and Domestic credit (% of GDP) in Turkey?
Offer a very short reply. 7.02. In the year 2005, what is the difference between the Domestic credit (% of GDP) in Macedonia and Domestic credit (% of GDP) in Turkey?
Ensure brevity in your answer.  1.08. In the year 2006, what is the difference between the Domestic credit (% of GDP) in Barbados and Domestic credit (% of GDP) in Colombia?
Provide a succinct answer. 38.84. In the year 2006, what is the difference between the Domestic credit (% of GDP) of Barbados and Domestic credit (% of GDP) of Macedonia?
Your answer should be very brief. 44.19. In the year 2006, what is the difference between the Domestic credit (% of GDP) of Barbados and Domestic credit (% of GDP) of Turkey?
Make the answer very short. 46.27. In the year 2006, what is the difference between the Domestic credit (% of GDP) in Colombia and Domestic credit (% of GDP) in Macedonia?
Your answer should be compact. 5.35. In the year 2006, what is the difference between the Domestic credit (% of GDP) in Colombia and Domestic credit (% of GDP) in Turkey?
Your response must be concise. 7.42. In the year 2006, what is the difference between the Domestic credit (% of GDP) of Macedonia and Domestic credit (% of GDP) of Turkey?
Provide a short and direct response. 2.07. In the year 2007, what is the difference between the Domestic credit (% of GDP) in Barbados and Domestic credit (% of GDP) in Colombia?
Provide a succinct answer. 35.71. In the year 2007, what is the difference between the Domestic credit (% of GDP) in Barbados and Domestic credit (% of GDP) in Macedonia?
Your response must be concise. 38.38. In the year 2007, what is the difference between the Domestic credit (% of GDP) in Barbados and Domestic credit (% of GDP) in Turkey?
Provide a succinct answer. 43.85. In the year 2007, what is the difference between the Domestic credit (% of GDP) in Colombia and Domestic credit (% of GDP) in Macedonia?
Keep it short and to the point. 2.68. In the year 2007, what is the difference between the Domestic credit (% of GDP) in Colombia and Domestic credit (% of GDP) in Turkey?
Provide a succinct answer. 8.14. In the year 2007, what is the difference between the Domestic credit (% of GDP) of Macedonia and Domestic credit (% of GDP) of Turkey?
Keep it short and to the point. 5.46. In the year 2008, what is the difference between the Domestic credit (% of GDP) of Barbados and Domestic credit (% of GDP) of Colombia?
Your answer should be very brief. 41.11. In the year 2008, what is the difference between the Domestic credit (% of GDP) of Barbados and Domestic credit (% of GDP) of Macedonia?
Provide a short and direct response. 36.7. In the year 2008, what is the difference between the Domestic credit (% of GDP) in Barbados and Domestic credit (% of GDP) in Turkey?
Your response must be concise. 43.62. In the year 2008, what is the difference between the Domestic credit (% of GDP) of Colombia and Domestic credit (% of GDP) of Macedonia?
Offer a terse response. -4.41. In the year 2008, what is the difference between the Domestic credit (% of GDP) of Colombia and Domestic credit (% of GDP) of Turkey?
Provide a succinct answer. 2.51. In the year 2008, what is the difference between the Domestic credit (% of GDP) of Macedonia and Domestic credit (% of GDP) of Turkey?
Offer a terse response. 6.92. In the year 2009, what is the difference between the Domestic credit (% of GDP) of Barbados and Domestic credit (% of GDP) of Colombia?
Keep it short and to the point. 40.44. In the year 2009, what is the difference between the Domestic credit (% of GDP) of Barbados and Domestic credit (% of GDP) of Macedonia?
Your answer should be compact. 36.95. In the year 2009, what is the difference between the Domestic credit (% of GDP) in Barbados and Domestic credit (% of GDP) in Turkey?
Your answer should be compact. 41.23. In the year 2009, what is the difference between the Domestic credit (% of GDP) in Colombia and Domestic credit (% of GDP) in Macedonia?
Your answer should be very brief. -3.5. In the year 2009, what is the difference between the Domestic credit (% of GDP) of Colombia and Domestic credit (% of GDP) of Turkey?
Provide a succinct answer. 0.79. In the year 2009, what is the difference between the Domestic credit (% of GDP) of Macedonia and Domestic credit (% of GDP) of Turkey?
Provide a short and direct response. 4.29. What is the ratio of the Domestic credit (% of GDP) of Barbados in 2002 to that in 2003?
Keep it short and to the point. 0.97. What is the ratio of the Domestic credit (% of GDP) of Colombia in 2002 to that in 2003?
Offer a very short reply. 1.02. What is the ratio of the Domestic credit (% of GDP) in Macedonia in 2002 to that in 2003?
Ensure brevity in your answer.  0.95. What is the ratio of the Domestic credit (% of GDP) in Turkey in 2002 to that in 2003?
Your response must be concise. 1. What is the ratio of the Domestic credit (% of GDP) of Barbados in 2002 to that in 2004?
Provide a short and direct response. 0.9. What is the ratio of the Domestic credit (% of GDP) in Colombia in 2002 to that in 2004?
Make the answer very short. 0.93. What is the ratio of the Domestic credit (% of GDP) in Macedonia in 2002 to that in 2004?
Keep it short and to the point. 0.8. What is the ratio of the Domestic credit (% of GDP) of Turkey in 2002 to that in 2004?
Give a very brief answer. 0.84. What is the ratio of the Domestic credit (% of GDP) of Barbados in 2002 to that in 2005?
Provide a succinct answer. 0.83. What is the ratio of the Domestic credit (% of GDP) of Colombia in 2002 to that in 2005?
Your answer should be very brief. 0.86. What is the ratio of the Domestic credit (% of GDP) in Macedonia in 2002 to that in 2005?
Offer a terse response. 0.71. What is the ratio of the Domestic credit (% of GDP) of Turkey in 2002 to that in 2005?
Offer a terse response. 0.65. What is the ratio of the Domestic credit (% of GDP) in Barbados in 2002 to that in 2006?
Offer a terse response. 0.82. What is the ratio of the Domestic credit (% of GDP) of Colombia in 2002 to that in 2006?
Provide a succinct answer. 0.76. What is the ratio of the Domestic credit (% of GDP) of Macedonia in 2002 to that in 2006?
Provide a short and direct response. 0.59. What is the ratio of the Domestic credit (% of GDP) in Turkey in 2002 to that in 2006?
Offer a terse response. 0.56. What is the ratio of the Domestic credit (% of GDP) of Barbados in 2002 to that in 2007?
Offer a terse response. 0.81. What is the ratio of the Domestic credit (% of GDP) in Colombia in 2002 to that in 2007?
Give a very brief answer. 0.67. What is the ratio of the Domestic credit (% of GDP) in Macedonia in 2002 to that in 2007?
Offer a very short reply. 0.48. What is the ratio of the Domestic credit (% of GDP) of Turkey in 2002 to that in 2007?
Provide a succinct answer. 0.49. What is the ratio of the Domestic credit (% of GDP) of Barbados in 2002 to that in 2008?
Provide a short and direct response. 0.75. What is the ratio of the Domestic credit (% of GDP) in Colombia in 2002 to that in 2008?
Make the answer very short. 0.67. What is the ratio of the Domestic credit (% of GDP) in Macedonia in 2002 to that in 2008?
Your response must be concise. 0.4. What is the ratio of the Domestic credit (% of GDP) in Turkey in 2002 to that in 2008?
Ensure brevity in your answer.  0.41. What is the ratio of the Domestic credit (% of GDP) of Barbados in 2002 to that in 2009?
Your answer should be compact. 0.74. What is the ratio of the Domestic credit (% of GDP) of Colombia in 2002 to that in 2009?
Keep it short and to the point. 0.63. What is the ratio of the Domestic credit (% of GDP) in Macedonia in 2002 to that in 2009?
Your answer should be very brief. 0.38. What is the ratio of the Domestic credit (% of GDP) of Turkey in 2002 to that in 2009?
Your response must be concise. 0.37. What is the ratio of the Domestic credit (% of GDP) of Barbados in 2003 to that in 2004?
Your response must be concise. 0.93. What is the ratio of the Domestic credit (% of GDP) in Colombia in 2003 to that in 2004?
Offer a terse response. 0.91. What is the ratio of the Domestic credit (% of GDP) of Macedonia in 2003 to that in 2004?
Keep it short and to the point. 0.84. What is the ratio of the Domestic credit (% of GDP) in Turkey in 2003 to that in 2004?
Give a very brief answer. 0.84. What is the ratio of the Domestic credit (% of GDP) of Barbados in 2003 to that in 2005?
Offer a terse response. 0.86. What is the ratio of the Domestic credit (% of GDP) of Colombia in 2003 to that in 2005?
Provide a short and direct response. 0.85. What is the ratio of the Domestic credit (% of GDP) in Macedonia in 2003 to that in 2005?
Provide a short and direct response. 0.75. What is the ratio of the Domestic credit (% of GDP) of Turkey in 2003 to that in 2005?
Ensure brevity in your answer.  0.65. What is the ratio of the Domestic credit (% of GDP) in Barbados in 2003 to that in 2006?
Your answer should be compact. 0.85. What is the ratio of the Domestic credit (% of GDP) in Colombia in 2003 to that in 2006?
Ensure brevity in your answer.  0.75. What is the ratio of the Domestic credit (% of GDP) in Macedonia in 2003 to that in 2006?
Your answer should be very brief. 0.63. What is the ratio of the Domestic credit (% of GDP) in Turkey in 2003 to that in 2006?
Provide a short and direct response. 0.56. What is the ratio of the Domestic credit (% of GDP) of Barbados in 2003 to that in 2007?
Your response must be concise. 0.83. What is the ratio of the Domestic credit (% of GDP) in Colombia in 2003 to that in 2007?
Your answer should be compact. 0.66. What is the ratio of the Domestic credit (% of GDP) of Macedonia in 2003 to that in 2007?
Your answer should be compact. 0.5. What is the ratio of the Domestic credit (% of GDP) of Turkey in 2003 to that in 2007?
Offer a terse response. 0.49. What is the ratio of the Domestic credit (% of GDP) in Barbados in 2003 to that in 2008?
Give a very brief answer. 0.78. What is the ratio of the Domestic credit (% of GDP) in Colombia in 2003 to that in 2008?
Provide a succinct answer. 0.66. What is the ratio of the Domestic credit (% of GDP) in Macedonia in 2003 to that in 2008?
Provide a succinct answer. 0.42. What is the ratio of the Domestic credit (% of GDP) of Turkey in 2003 to that in 2008?
Provide a short and direct response. 0.41. What is the ratio of the Domestic credit (% of GDP) in Barbados in 2003 to that in 2009?
Provide a succinct answer. 0.76. What is the ratio of the Domestic credit (% of GDP) in Colombia in 2003 to that in 2009?
Your response must be concise. 0.62. What is the ratio of the Domestic credit (% of GDP) in Macedonia in 2003 to that in 2009?
Give a very brief answer. 0.4. What is the ratio of the Domestic credit (% of GDP) of Turkey in 2003 to that in 2009?
Give a very brief answer. 0.37. What is the ratio of the Domestic credit (% of GDP) of Barbados in 2004 to that in 2005?
Provide a succinct answer. 0.92. What is the ratio of the Domestic credit (% of GDP) of Colombia in 2004 to that in 2005?
Give a very brief answer. 0.93. What is the ratio of the Domestic credit (% of GDP) of Macedonia in 2004 to that in 2005?
Your response must be concise. 0.9. What is the ratio of the Domestic credit (% of GDP) in Turkey in 2004 to that in 2005?
Your answer should be compact. 0.78. What is the ratio of the Domestic credit (% of GDP) in Barbados in 2004 to that in 2006?
Offer a very short reply. 0.91. What is the ratio of the Domestic credit (% of GDP) of Colombia in 2004 to that in 2006?
Your response must be concise. 0.82. What is the ratio of the Domestic credit (% of GDP) in Macedonia in 2004 to that in 2006?
Provide a short and direct response. 0.75. What is the ratio of the Domestic credit (% of GDP) of Turkey in 2004 to that in 2006?
Offer a terse response. 0.67. What is the ratio of the Domestic credit (% of GDP) in Barbados in 2004 to that in 2007?
Provide a succinct answer. 0.9. What is the ratio of the Domestic credit (% of GDP) in Colombia in 2004 to that in 2007?
Keep it short and to the point. 0.72. What is the ratio of the Domestic credit (% of GDP) in Macedonia in 2004 to that in 2007?
Your response must be concise. 0.6. What is the ratio of the Domestic credit (% of GDP) of Turkey in 2004 to that in 2007?
Offer a very short reply. 0.59. What is the ratio of the Domestic credit (% of GDP) of Barbados in 2004 to that in 2008?
Your answer should be compact. 0.84. What is the ratio of the Domestic credit (% of GDP) of Colombia in 2004 to that in 2008?
Your response must be concise. 0.72. What is the ratio of the Domestic credit (% of GDP) of Macedonia in 2004 to that in 2008?
Provide a succinct answer. 0.5. What is the ratio of the Domestic credit (% of GDP) in Turkey in 2004 to that in 2008?
Provide a succinct answer. 0.49. What is the ratio of the Domestic credit (% of GDP) of Barbados in 2004 to that in 2009?
Offer a very short reply. 0.82. What is the ratio of the Domestic credit (% of GDP) of Colombia in 2004 to that in 2009?
Make the answer very short. 0.68. What is the ratio of the Domestic credit (% of GDP) in Macedonia in 2004 to that in 2009?
Give a very brief answer. 0.48. What is the ratio of the Domestic credit (% of GDP) in Turkey in 2004 to that in 2009?
Make the answer very short. 0.44. What is the ratio of the Domestic credit (% of GDP) of Barbados in 2005 to that in 2006?
Your answer should be very brief. 0.99. What is the ratio of the Domestic credit (% of GDP) in Colombia in 2005 to that in 2006?
Provide a short and direct response. 0.88. What is the ratio of the Domestic credit (% of GDP) in Macedonia in 2005 to that in 2006?
Your response must be concise. 0.83. What is the ratio of the Domestic credit (% of GDP) in Turkey in 2005 to that in 2006?
Your answer should be very brief. 0.86. What is the ratio of the Domestic credit (% of GDP) of Barbados in 2005 to that in 2007?
Give a very brief answer. 0.97. What is the ratio of the Domestic credit (% of GDP) of Colombia in 2005 to that in 2007?
Ensure brevity in your answer.  0.78. What is the ratio of the Domestic credit (% of GDP) in Macedonia in 2005 to that in 2007?
Keep it short and to the point. 0.67. What is the ratio of the Domestic credit (% of GDP) of Turkey in 2005 to that in 2007?
Offer a terse response. 0.75. What is the ratio of the Domestic credit (% of GDP) of Barbados in 2005 to that in 2008?
Your answer should be compact. 0.9. What is the ratio of the Domestic credit (% of GDP) in Colombia in 2005 to that in 2008?
Give a very brief answer. 0.78. What is the ratio of the Domestic credit (% of GDP) in Macedonia in 2005 to that in 2008?
Provide a short and direct response. 0.55. What is the ratio of the Domestic credit (% of GDP) in Turkey in 2005 to that in 2008?
Make the answer very short. 0.63. What is the ratio of the Domestic credit (% of GDP) in Barbados in 2005 to that in 2009?
Give a very brief answer. 0.89. What is the ratio of the Domestic credit (% of GDP) in Colombia in 2005 to that in 2009?
Offer a terse response. 0.73. What is the ratio of the Domestic credit (% of GDP) of Macedonia in 2005 to that in 2009?
Make the answer very short. 0.54. What is the ratio of the Domestic credit (% of GDP) in Turkey in 2005 to that in 2009?
Provide a succinct answer. 0.57. What is the ratio of the Domestic credit (% of GDP) of Barbados in 2006 to that in 2007?
Offer a terse response. 0.98. What is the ratio of the Domestic credit (% of GDP) in Colombia in 2006 to that in 2007?
Give a very brief answer. 0.89. What is the ratio of the Domestic credit (% of GDP) in Macedonia in 2006 to that in 2007?
Keep it short and to the point. 0.8. What is the ratio of the Domestic credit (% of GDP) of Turkey in 2006 to that in 2007?
Offer a terse response. 0.88. What is the ratio of the Domestic credit (% of GDP) of Barbados in 2006 to that in 2008?
Your answer should be compact. 0.92. What is the ratio of the Domestic credit (% of GDP) of Colombia in 2006 to that in 2008?
Make the answer very short. 0.88. What is the ratio of the Domestic credit (% of GDP) of Macedonia in 2006 to that in 2008?
Keep it short and to the point. 0.67. What is the ratio of the Domestic credit (% of GDP) in Turkey in 2006 to that in 2008?
Make the answer very short. 0.74. What is the ratio of the Domestic credit (% of GDP) of Barbados in 2006 to that in 2009?
Ensure brevity in your answer.  0.9. What is the ratio of the Domestic credit (% of GDP) of Colombia in 2006 to that in 2009?
Ensure brevity in your answer.  0.83. What is the ratio of the Domestic credit (% of GDP) in Macedonia in 2006 to that in 2009?
Your answer should be very brief. 0.64. What is the ratio of the Domestic credit (% of GDP) of Turkey in 2006 to that in 2009?
Your answer should be compact. 0.66. What is the ratio of the Domestic credit (% of GDP) in Barbados in 2007 to that in 2008?
Make the answer very short. 0.93. What is the ratio of the Domestic credit (% of GDP) of Macedonia in 2007 to that in 2008?
Ensure brevity in your answer.  0.83. What is the ratio of the Domestic credit (% of GDP) of Turkey in 2007 to that in 2008?
Your response must be concise. 0.84. What is the ratio of the Domestic credit (% of GDP) of Barbados in 2007 to that in 2009?
Give a very brief answer. 0.91. What is the ratio of the Domestic credit (% of GDP) of Colombia in 2007 to that in 2009?
Keep it short and to the point. 0.94. What is the ratio of the Domestic credit (% of GDP) in Macedonia in 2007 to that in 2009?
Offer a terse response. 0.8. What is the ratio of the Domestic credit (% of GDP) of Turkey in 2007 to that in 2009?
Offer a very short reply. 0.75. What is the ratio of the Domestic credit (% of GDP) in Barbados in 2008 to that in 2009?
Make the answer very short. 0.98. What is the ratio of the Domestic credit (% of GDP) in Colombia in 2008 to that in 2009?
Keep it short and to the point. 0.94. What is the ratio of the Domestic credit (% of GDP) of Macedonia in 2008 to that in 2009?
Give a very brief answer. 0.97. What is the ratio of the Domestic credit (% of GDP) of Turkey in 2008 to that in 2009?
Ensure brevity in your answer.  0.9. What is the difference between the highest and the second highest Domestic credit (% of GDP) in Barbados?
Provide a succinct answer. 1.58. What is the difference between the highest and the second highest Domestic credit (% of GDP) in Colombia?
Offer a very short reply. 2.24. What is the difference between the highest and the second highest Domestic credit (% of GDP) of Macedonia?
Offer a very short reply. 1.33. What is the difference between the highest and the second highest Domestic credit (% of GDP) in Turkey?
Keep it short and to the point. 3.96. What is the difference between the highest and the lowest Domestic credit (% of GDP) of Barbados?
Provide a succinct answer. 21.16. What is the difference between the highest and the lowest Domestic credit (% of GDP) of Colombia?
Provide a short and direct response. 15.07. What is the difference between the highest and the lowest Domestic credit (% of GDP) of Macedonia?
Keep it short and to the point. 26.79. What is the difference between the highest and the lowest Domestic credit (% of GDP) of Turkey?
Give a very brief answer. 24.65. 